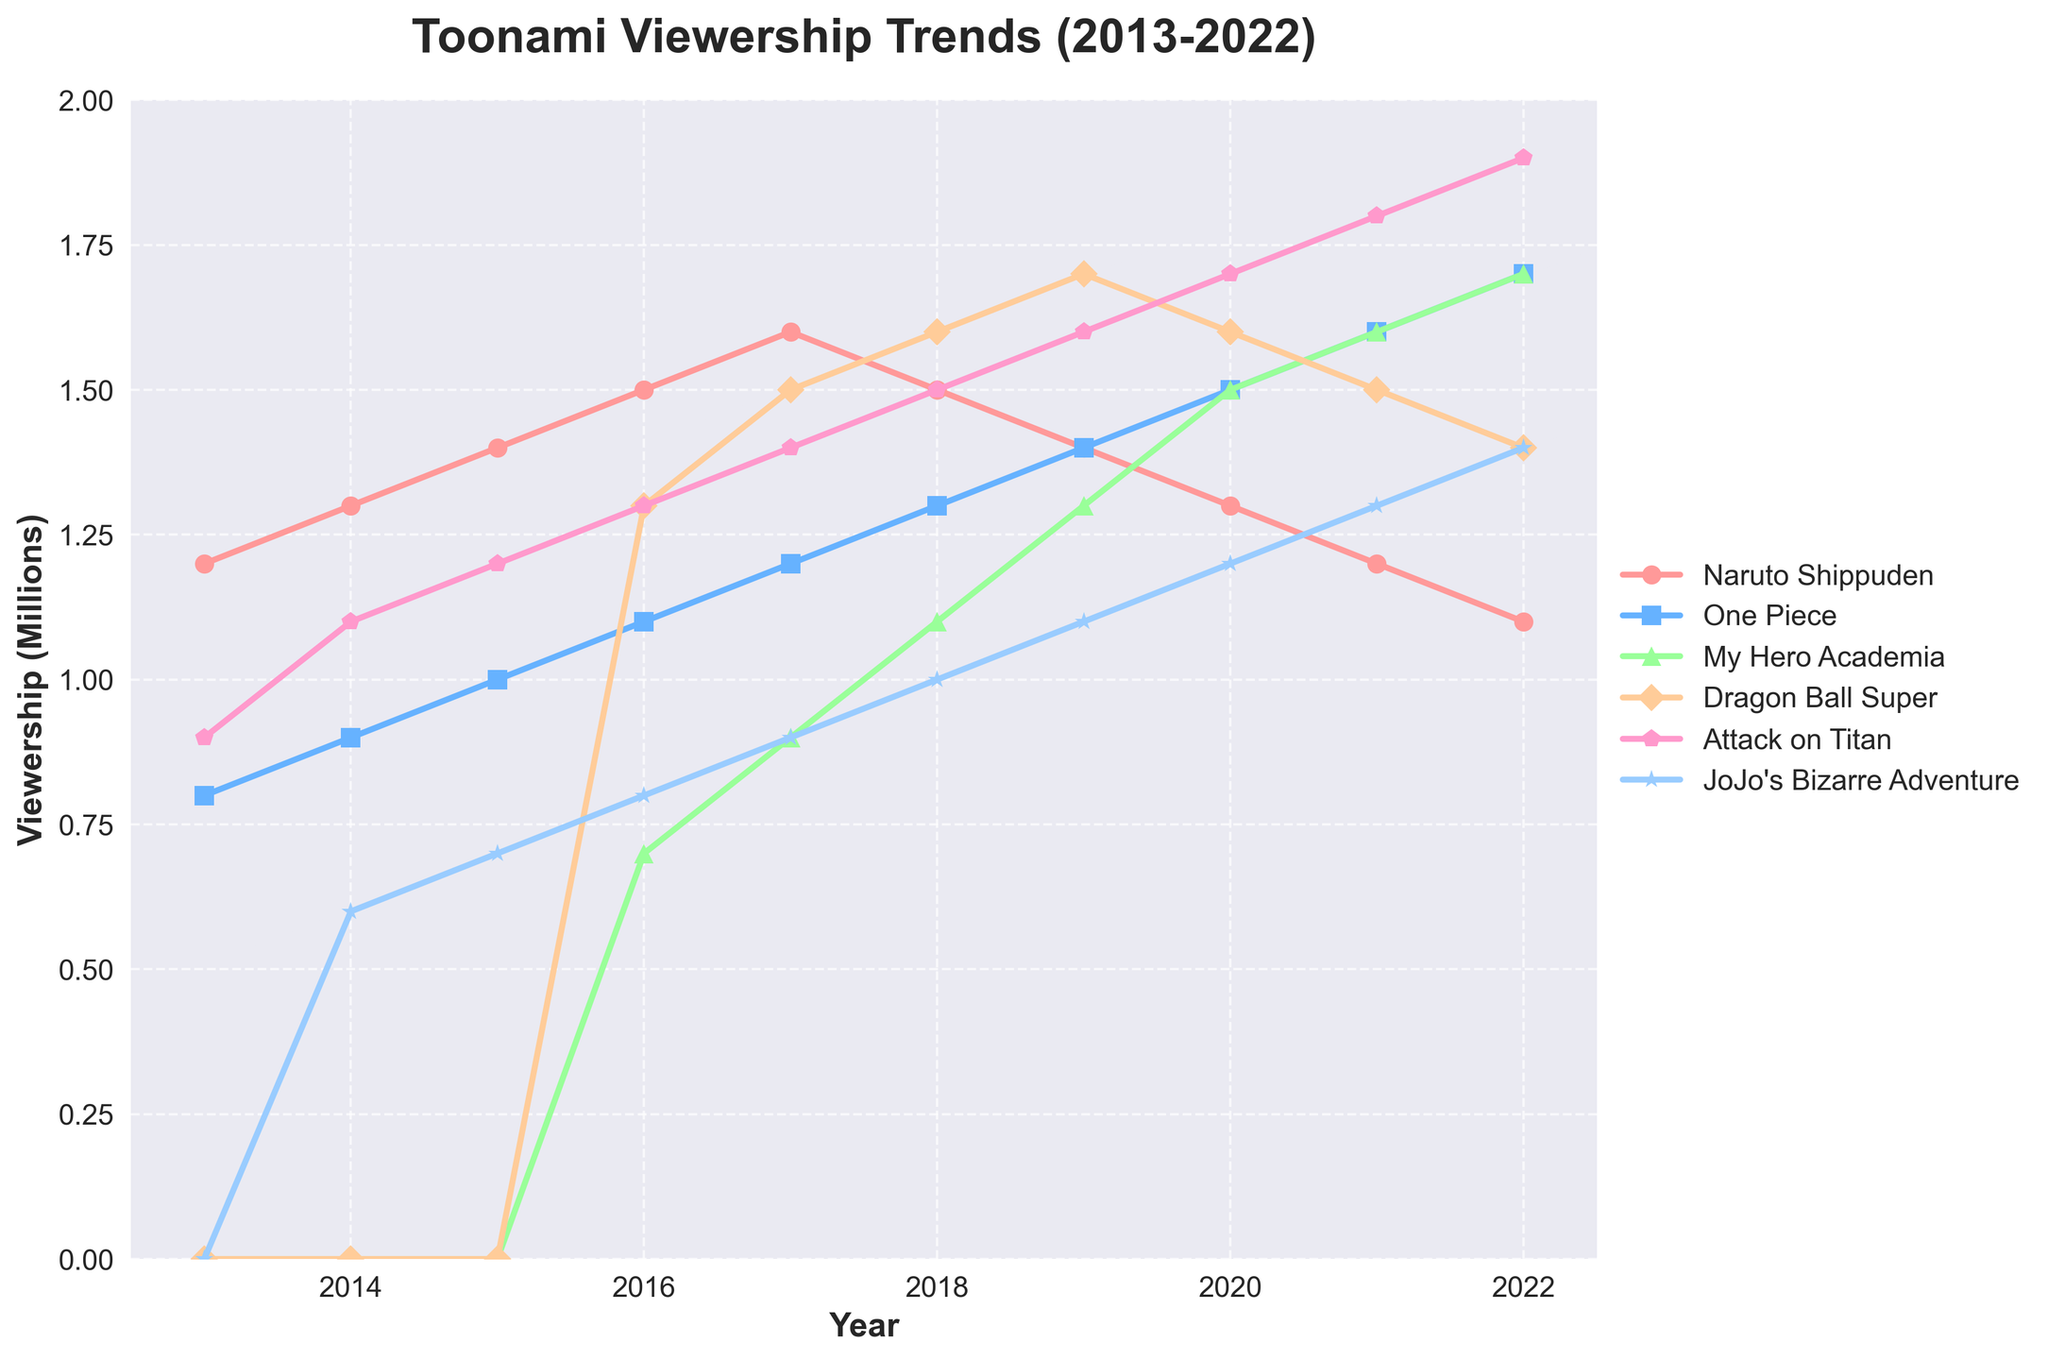what's the peak viewership year for Attack on Titan? By looking at the trend line for Attack on Titan, we can see that the maximum value (peak) is at the year 2022 with a viewership of 1.9 million.
Answer: 2022 compare the viewership of Naruto Shippuden and Dragon Ball Super in 2016. Which had higher viewership? Check the value at 2016 for both series. Naruto Shippuden had 1.5 million viewers, while Dragon Ball Super had 1.3 million. Naruto Shippuden had a higher viewership.
Answer: Naruto Shippuden what's the average viewership for One Piece from 2013 to 2017? Add the viewership values for One Piece from 2013 to 2017 (0.8 + 0.9 + 1.0 + 1.1 + 1.2 = 5.0 million) and divide by the number of years (5). The average is 5.0 / 5 = 1.0 million.
Answer: 1.0 million did Attack on Titan ever surpass Naruto Shippuden in viewership? If so, in what year? Compare the viewership values for both series across all years. Attack on Titan surpassed Naruto Shippuden from 2020 to 2022.
Answer: 2020 to 2022 which anime series had the most consistent viewership trend from 2013 to 2022? By observing the trend lines' slopes and variations over the years, it's clear that Naruto Shippuden had a gradually declining but more consistent trend compared to the steeper changes in other series.
Answer: Naruto Shippuden which series showed its highest increase in viewership from one year to the next? Compare the year-to-year increases for all series. My Hero Academia showed the highest increase from 2016 (0.7 million) to 2017 (0.9 million), which is an increase of 0.2 million viewers.
Answer: My Hero Academia in 2019, how did the viewership of JoJo's Bizarre Adventure compare to Attack on Titan? Check the values for 2019: JoJo's Bizarre Adventure had 1.1 million viewers and Attack on Titan had 1.6 million viewers. Attack on Titan had higher viewership.
Answer: Attack on Titan which series had the largest overall increase in viewership from its start year to 2022? Calculate the difference from the start year to 2022 for each series. One Piece increased from 0.8 million in 2013 to 1.7 million in 2022, which is an increase of 0.9 million. This is the largest overall increase compared to other series.
Answer: One Piece 